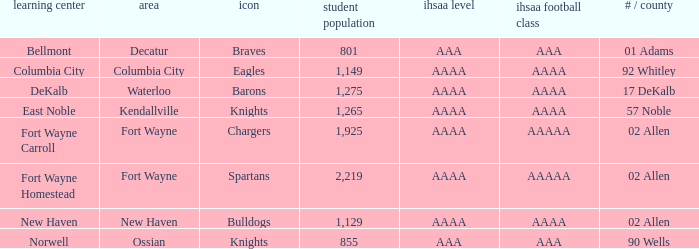What's the enrollment for Kendallville? 1265.0. 